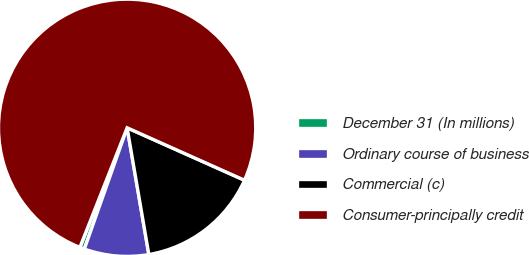Convert chart to OTSL. <chart><loc_0><loc_0><loc_500><loc_500><pie_chart><fcel>December 31 (In millions)<fcel>Ordinary course of business<fcel>Commercial (c)<fcel>Consumer-principally credit<nl><fcel>0.59%<fcel>8.1%<fcel>15.61%<fcel>75.7%<nl></chart> 